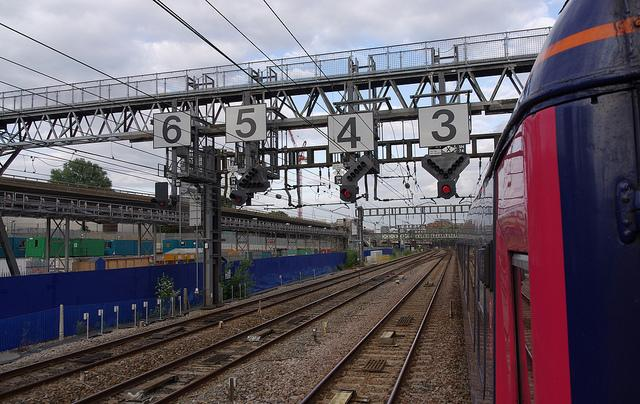What is the next number in the sequence?

Choices:
A) one
B) ten
C) two
D) eight two 